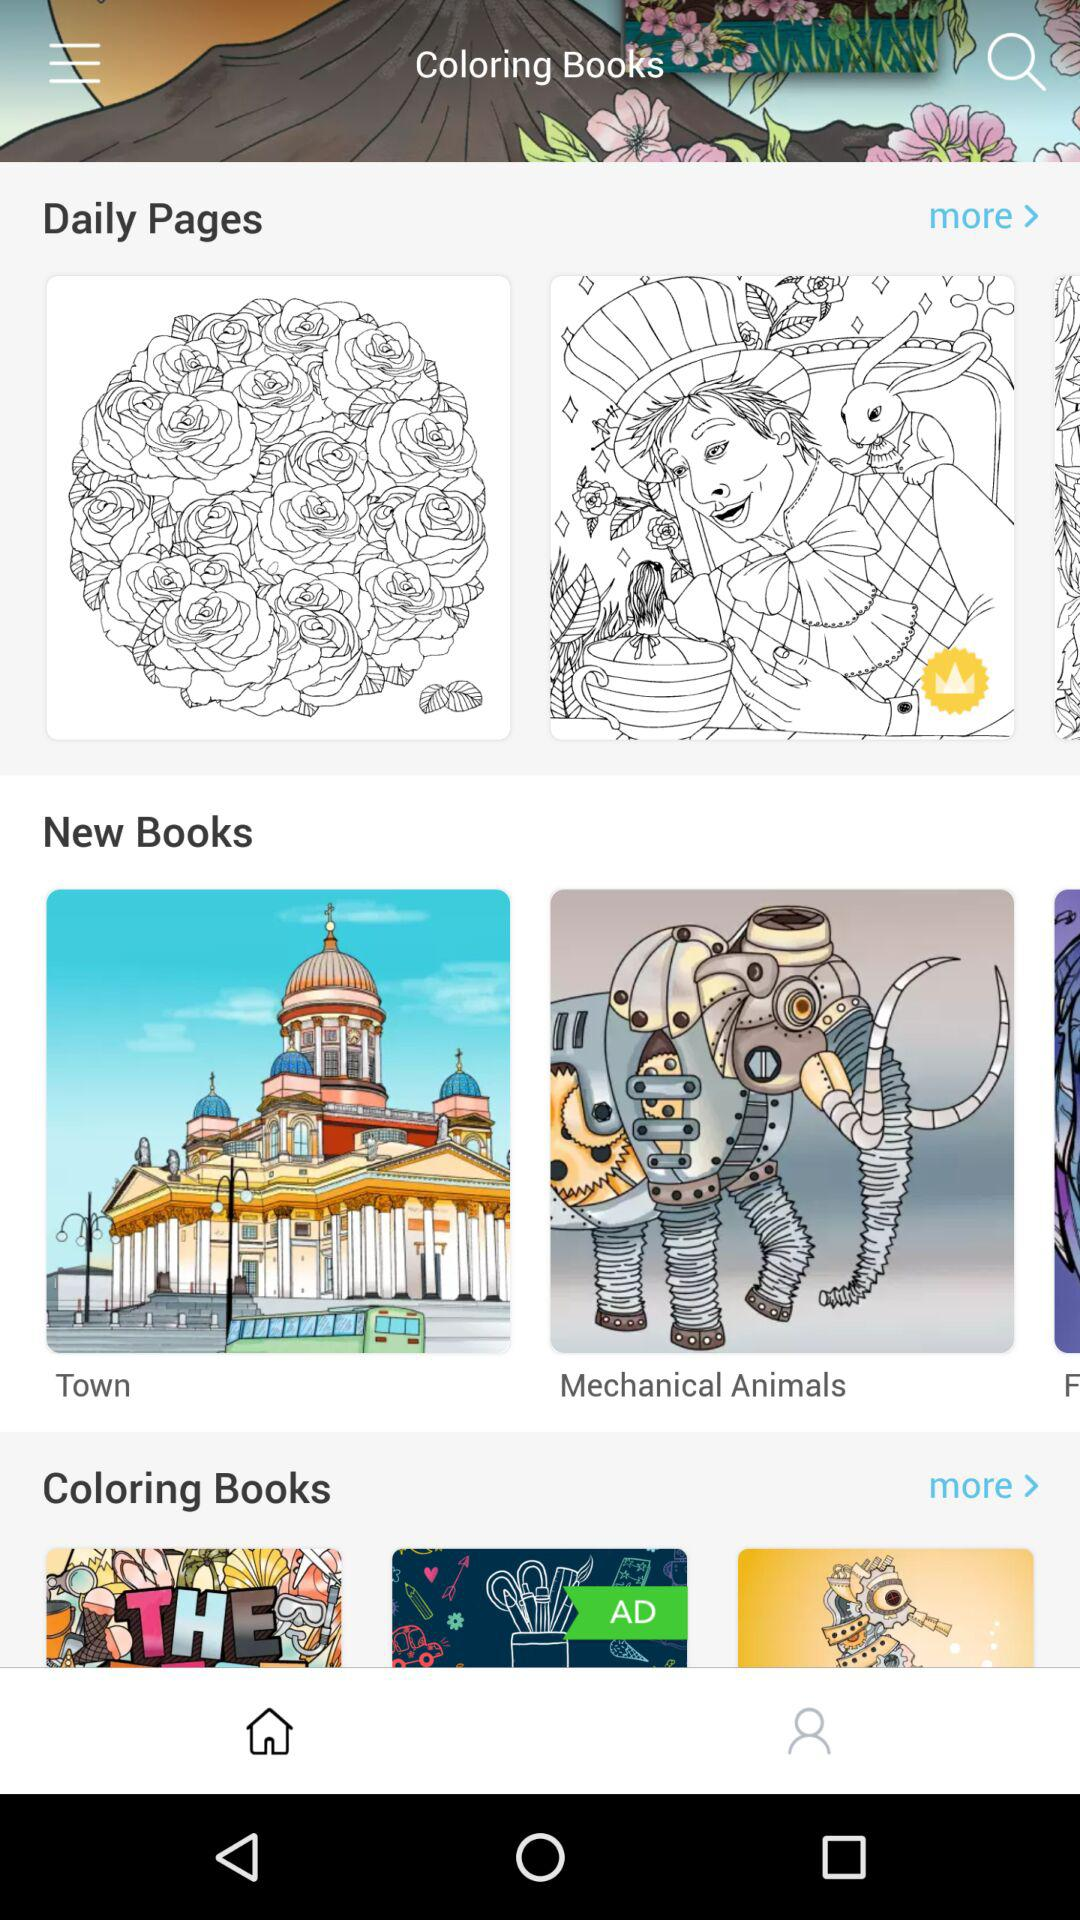What are the new books? The new books are "Town" and "Mechanical Animals". 